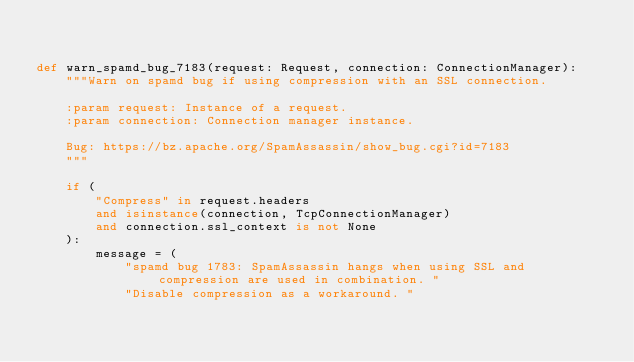<code> <loc_0><loc_0><loc_500><loc_500><_Python_>

def warn_spamd_bug_7183(request: Request, connection: ConnectionManager):
    """Warn on spamd bug if using compression with an SSL connection.

    :param request: Instance of a request.
    :param connection: Connection manager instance.

    Bug: https://bz.apache.org/SpamAssassin/show_bug.cgi?id=7183
    """

    if (
        "Compress" in request.headers
        and isinstance(connection, TcpConnectionManager)
        and connection.ssl_context is not None
    ):
        message = (
            "spamd bug 1783: SpamAssassin hangs when using SSL and compression are used in combination. "
            "Disable compression as a workaround. "</code> 